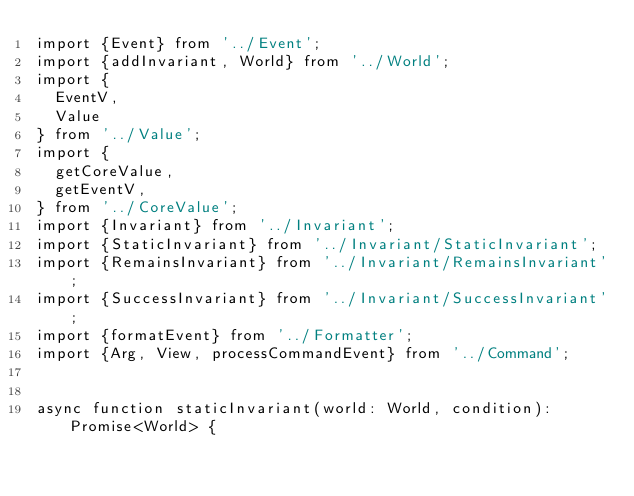Convert code to text. <code><loc_0><loc_0><loc_500><loc_500><_TypeScript_>import {Event} from '../Event';
import {addInvariant, World} from '../World';
import {
  EventV,
  Value
} from '../Value';
import {
  getCoreValue,
  getEventV,
} from '../CoreValue';
import {Invariant} from '../Invariant';
import {StaticInvariant} from '../Invariant/StaticInvariant';
import {RemainsInvariant} from '../Invariant/RemainsInvariant';
import {SuccessInvariant} from '../Invariant/SuccessInvariant';
import {formatEvent} from '../Formatter';
import {Arg, View, processCommandEvent} from '../Command';


async function staticInvariant(world: World, condition): Promise<World> {</code> 